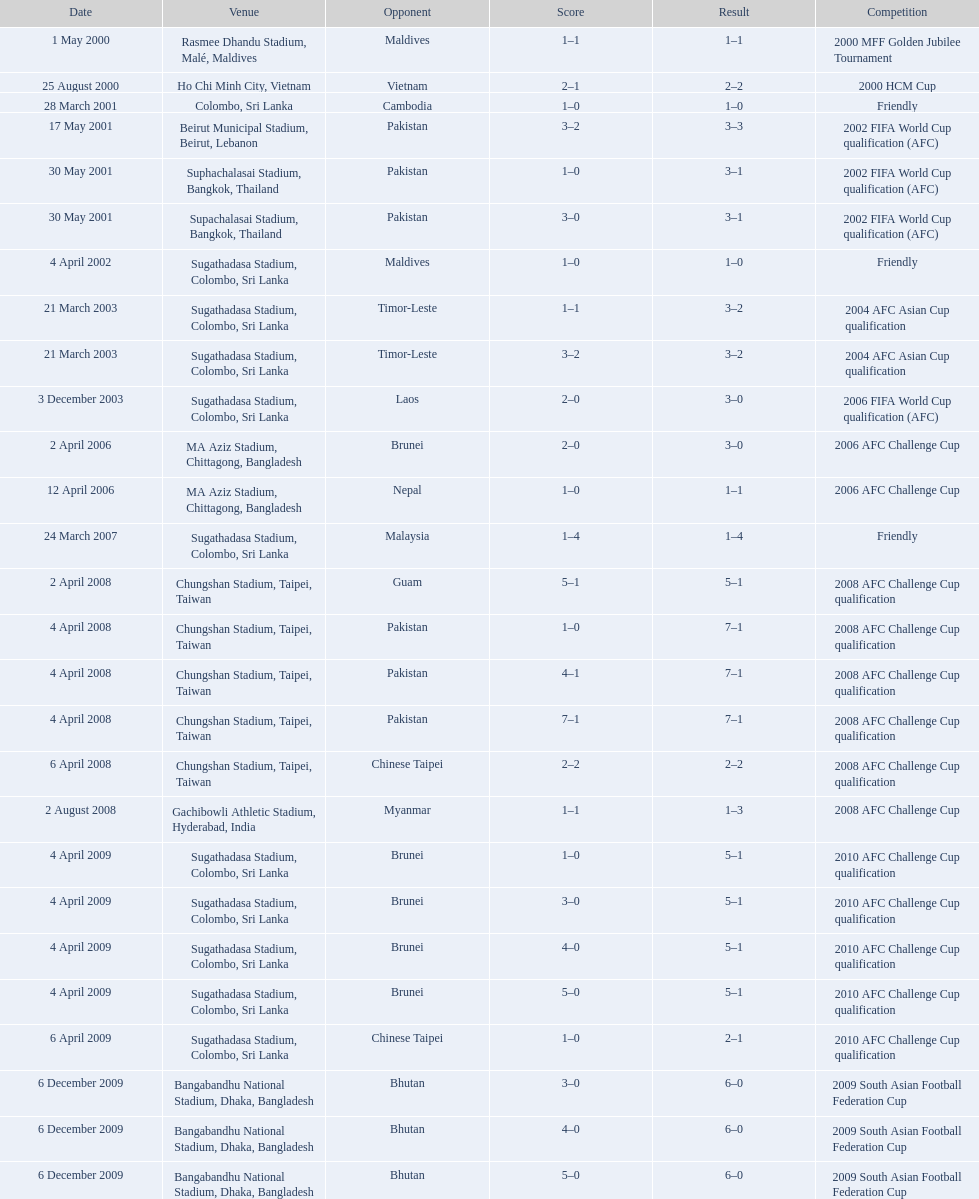Write the full table. {'header': ['Date', 'Venue', 'Opponent', 'Score', 'Result', 'Competition'], 'rows': [['1 May 2000', 'Rasmee Dhandu Stadium, Malé, Maldives', 'Maldives', '1–1', '1–1', '2000 MFF Golden Jubilee Tournament'], ['25 August 2000', 'Ho Chi Minh City, Vietnam', 'Vietnam', '2–1', '2–2', '2000 HCM Cup'], ['28 March 2001', 'Colombo, Sri Lanka', 'Cambodia', '1–0', '1–0', 'Friendly'], ['17 May 2001', 'Beirut Municipal Stadium, Beirut, Lebanon', 'Pakistan', '3–2', '3–3', '2002 FIFA World Cup qualification (AFC)'], ['30 May 2001', 'Suphachalasai Stadium, Bangkok, Thailand', 'Pakistan', '1–0', '3–1', '2002 FIFA World Cup qualification (AFC)'], ['30 May 2001', 'Supachalasai Stadium, Bangkok, Thailand', 'Pakistan', '3–0', '3–1', '2002 FIFA World Cup qualification (AFC)'], ['4 April 2002', 'Sugathadasa Stadium, Colombo, Sri Lanka', 'Maldives', '1–0', '1–0', 'Friendly'], ['21 March 2003', 'Sugathadasa Stadium, Colombo, Sri Lanka', 'Timor-Leste', '1–1', '3–2', '2004 AFC Asian Cup qualification'], ['21 March 2003', 'Sugathadasa Stadium, Colombo, Sri Lanka', 'Timor-Leste', '3–2', '3–2', '2004 AFC Asian Cup qualification'], ['3 December 2003', 'Sugathadasa Stadium, Colombo, Sri Lanka', 'Laos', '2–0', '3–0', '2006 FIFA World Cup qualification (AFC)'], ['2 April 2006', 'MA Aziz Stadium, Chittagong, Bangladesh', 'Brunei', '2–0', '3–0', '2006 AFC Challenge Cup'], ['12 April 2006', 'MA Aziz Stadium, Chittagong, Bangladesh', 'Nepal', '1–0', '1–1', '2006 AFC Challenge Cup'], ['24 March 2007', 'Sugathadasa Stadium, Colombo, Sri Lanka', 'Malaysia', '1–4', '1–4', 'Friendly'], ['2 April 2008', 'Chungshan Stadium, Taipei, Taiwan', 'Guam', '5–1', '5–1', '2008 AFC Challenge Cup qualification'], ['4 April 2008', 'Chungshan Stadium, Taipei, Taiwan', 'Pakistan', '1–0', '7–1', '2008 AFC Challenge Cup qualification'], ['4 April 2008', 'Chungshan Stadium, Taipei, Taiwan', 'Pakistan', '4–1', '7–1', '2008 AFC Challenge Cup qualification'], ['4 April 2008', 'Chungshan Stadium, Taipei, Taiwan', 'Pakistan', '7–1', '7–1', '2008 AFC Challenge Cup qualification'], ['6 April 2008', 'Chungshan Stadium, Taipei, Taiwan', 'Chinese Taipei', '2–2', '2–2', '2008 AFC Challenge Cup qualification'], ['2 August 2008', 'Gachibowli Athletic Stadium, Hyderabad, India', 'Myanmar', '1–1', '1–3', '2008 AFC Challenge Cup'], ['4 April 2009', 'Sugathadasa Stadium, Colombo, Sri Lanka', 'Brunei', '1–0', '5–1', '2010 AFC Challenge Cup qualification'], ['4 April 2009', 'Sugathadasa Stadium, Colombo, Sri Lanka', 'Brunei', '3–0', '5–1', '2010 AFC Challenge Cup qualification'], ['4 April 2009', 'Sugathadasa Stadium, Colombo, Sri Lanka', 'Brunei', '4–0', '5–1', '2010 AFC Challenge Cup qualification'], ['4 April 2009', 'Sugathadasa Stadium, Colombo, Sri Lanka', 'Brunei', '5–0', '5–1', '2010 AFC Challenge Cup qualification'], ['6 April 2009', 'Sugathadasa Stadium, Colombo, Sri Lanka', 'Chinese Taipei', '1–0', '2–1', '2010 AFC Challenge Cup qualification'], ['6 December 2009', 'Bangabandhu National Stadium, Dhaka, Bangladesh', 'Bhutan', '3–0', '6–0', '2009 South Asian Football Federation Cup'], ['6 December 2009', 'Bangabandhu National Stadium, Dhaka, Bangladesh', 'Bhutan', '4–0', '6–0', '2009 South Asian Football Federation Cup'], ['6 December 2009', 'Bangabandhu National Stadium, Dhaka, Bangladesh', 'Bhutan', '5–0', '6–0', '2009 South Asian Football Federation Cup']]} In how many games did sri lanka score at least 2 goals? 16. 